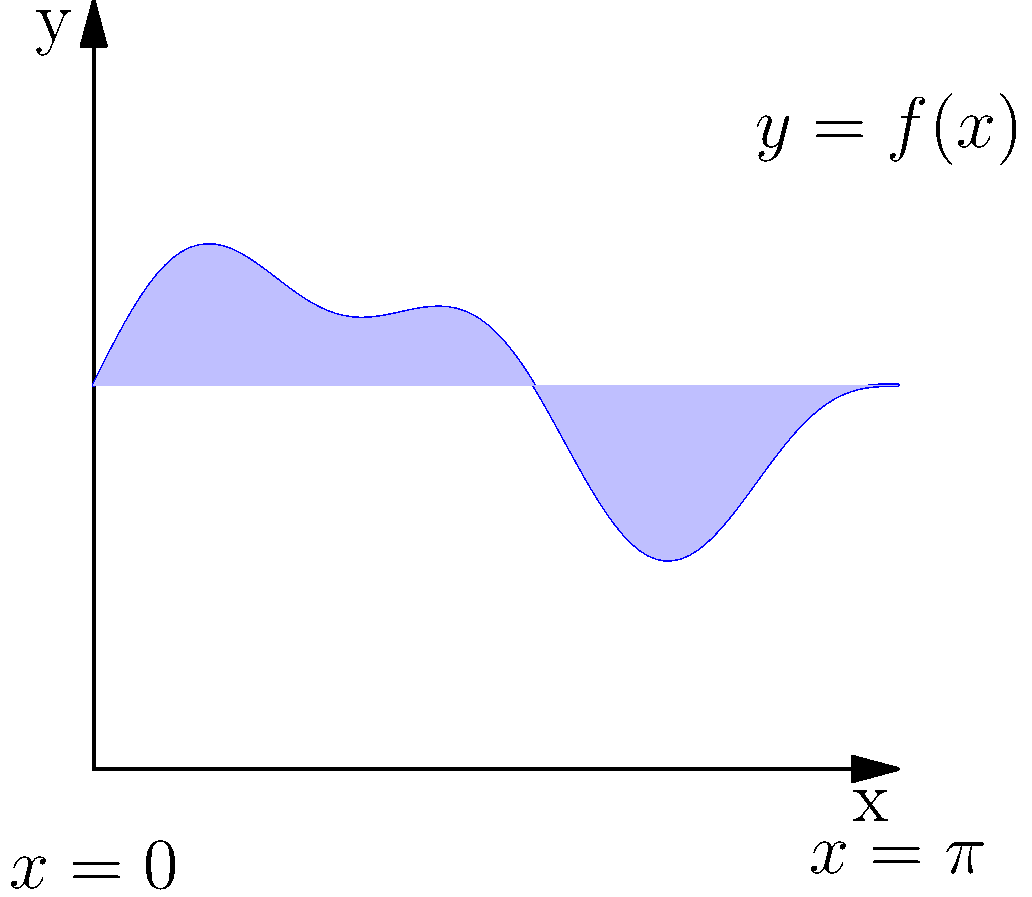In your procedural terrain generator, you've created a curve representing the terrain height using the function $f(x) = 0.5\sin(2x) + 1.5 + 0.2\sin(5x)$ over the interval $[0, \pi]$. Calculate the area under this curve, which represents the cross-sectional area of the terrain. Use the definite integral to find the exact value. To find the area under the curve, we need to integrate the function $f(x)$ over the given interval $[0, \pi]$. Let's break this down step-by-step:

1) The definite integral we need to evaluate is:

   $$\int_0^\pi (0.5\sin(2x) + 1.5 + 0.2\sin(5x)) dx$$

2) We can split this into three integrals:

   $$\int_0^\pi 0.5\sin(2x) dx + \int_0^\pi 1.5 dx + \int_0^\pi 0.2\sin(5x) dx$$

3) Let's evaluate each integral:

   a) $\int_0^\pi 0.5\sin(2x) dx$
      $= -0.25\cos(2x)|_0^\pi = -0.25(\cos(2\pi) - \cos(0)) = 0$

   b) $\int_0^\pi 1.5 dx = 1.5x|_0^\pi = 1.5\pi$

   c) $\int_0^\pi 0.2\sin(5x) dx$
      $= -0.04\cos(5x)|_0^\pi = -0.04(\cos(5\pi) - \cos(0)) = 0.08$

4) Sum up the results:

   $0 + 1.5\pi + 0.08 = 1.5\pi + 0.08$

Therefore, the exact area under the curve is $1.5\pi + 0.08$ square units.
Answer: $1.5\pi + 0.08$ square units 